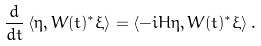<formula> <loc_0><loc_0><loc_500><loc_500>\frac { d } { d t } \left \langle \eta , W ( t ) ^ { * } \xi \right \rangle = \left \langle - i H \eta , W ( t ) ^ { * } \xi \right \rangle .</formula> 